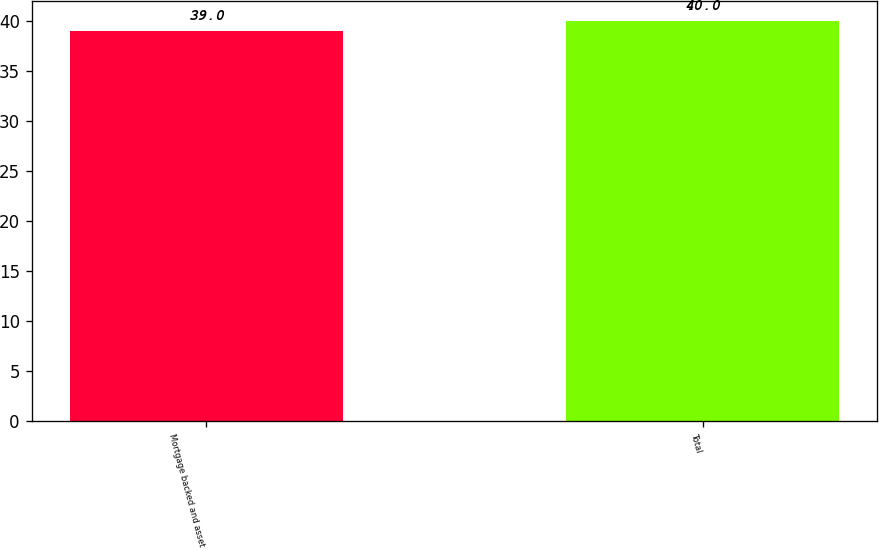<chart> <loc_0><loc_0><loc_500><loc_500><bar_chart><fcel>Mortgage backed and asset<fcel>Total<nl><fcel>39<fcel>40<nl></chart> 